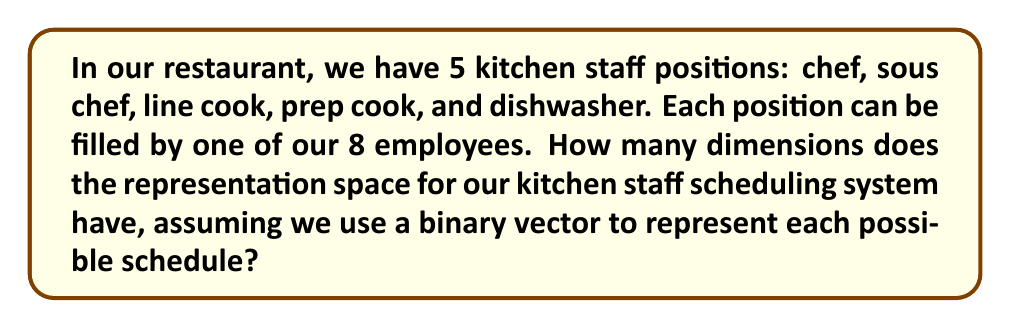Teach me how to tackle this problem. Let's approach this step-by-step:

1) In representation theory, we're dealing with vector spaces. Here, each possible schedule is a vector in our representation space.

2) For each position, we have a binary choice for each employee: they're either scheduled (1) or not scheduled (0) for that position.

3) This means for each position, we have 8 binary choices (one for each employee).

4) We can represent this as a binary vector of length 8 for each position. For example:
   $$(1,0,0,0,0,0,0,0)$$ might represent that the first employee is scheduled for a particular position.

5) We have 5 positions, so our complete schedule vector will be the concatenation of 5 such vectors, giving us a binary vector of length $5 * 8 = 40$.

6) In general, the dimension of a vector space is the number of components in each vector. 

7) Therefore, the dimension of our representation space is 40.

This 40-dimensional space can represent all possible schedules in our kitchen staff system, where each dimension corresponds to whether a specific employee is scheduled for a specific position.
Answer: 40 